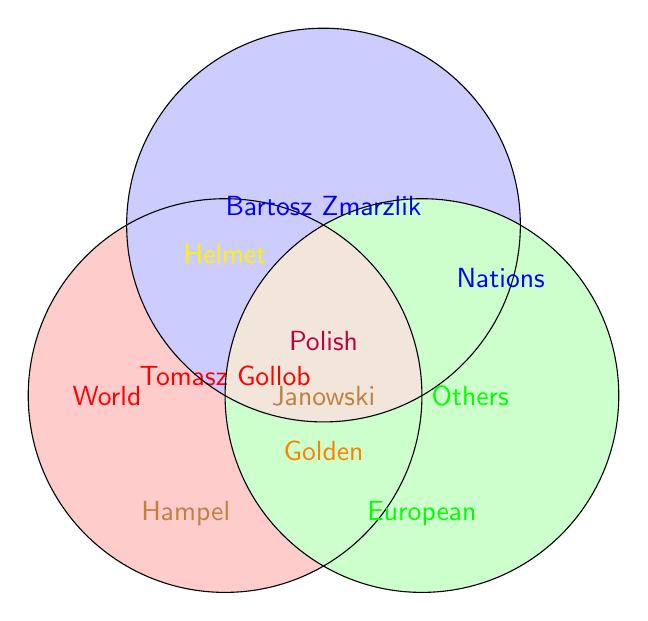Which rider is a World Champion and a Polish Champion? Tomasz Gollob and Bartosz Zmarzlik are the overlapping areas in World (red) and Polish (purple). Therefore, both of them have achieved these titles.
Answer: Tomasz Gollob and Bartosz Zmarzlik Which riders are part of the Speedway of Nations Winner group? By looking at the Nations circle (blue), we can see the names Bartosz Zmarzlik and Maciej Janowski.
Answer: Bartosz Zmarzlik and Maciej Janowski How many riders have won the Golden Helmet? The Golden Helmet (orange) overlaps with Tomasz Gollob, Bartosz Zmarzlik, and Jarosław Hampel. Hence, there are three riders.
Answer: 3 Who has achieved both the European and Polish Championships? The Polish (purple) and European (green) circles overlap only on Tomasz Gollob.
Answer: Tomasz Gollob Is there any rider who has won all listed achievements? The central overlap area where all circles (red, blue, green, orange, purple) intersect doesn't have any names listed. Hence, no one has won all achievements.
Answer: No Who is part of the European Champion group and won the Golden Helmet? The intersection of the European (green) and Golden Helmet (orange) circles contains Jarosław Hampel.
Answer: Jarosław Hampel Which rider does not appear in the Polish Champions group but has other achievements? Among the names listed in the diagram, Jarosław Hampel, who is in the green (European) and orange (Golden Helmet) circles, does not appear in the Polish (purple) circle.
Answer: Jarosław Hampel Who achieved the most types of titles? Tomasz Gollob appears in the maximum number of circle intersections: World (red), European (green), Polish (purple), and Golden Helmet (orange).
Answer: Tomasz Gollob Which two riders have at least one common achievement? Bartosz Zmarzlik and Tomasz Gollob are both World Champions (red) and Polish Champions (purple).
Answer: Bartosz Zmarzlik and Tomasz Gollob 